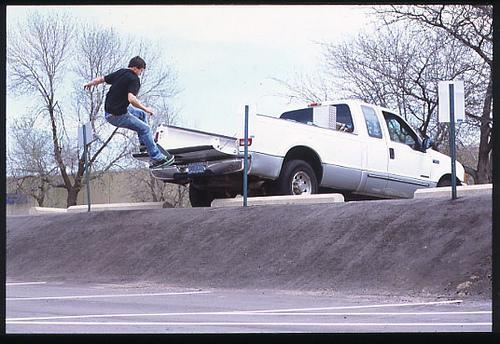How many people in the picture?
Give a very brief answer. 1. 